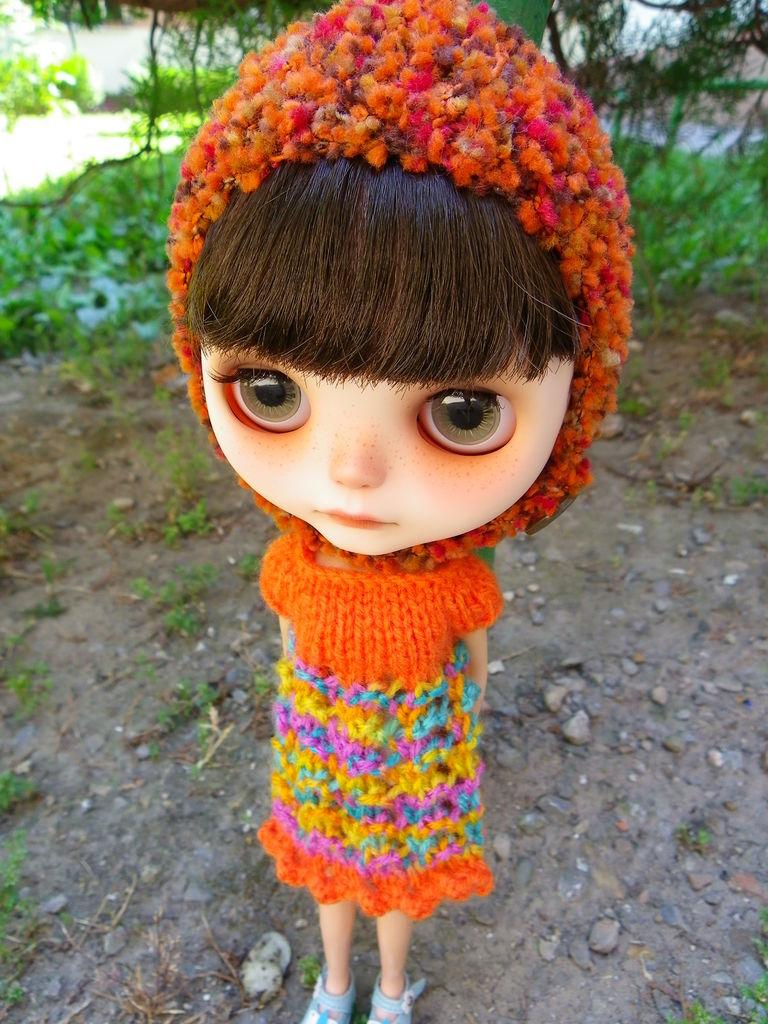What is the main subject in the center of the image? There is a doll in the center of the image. What can be seen in the background of the image? Ground, stones, plants, and trees are visible in the background of the image. What type of noise can be heard coming from the army in the image? There is no army present in the image, so no noise can be heard from them. 